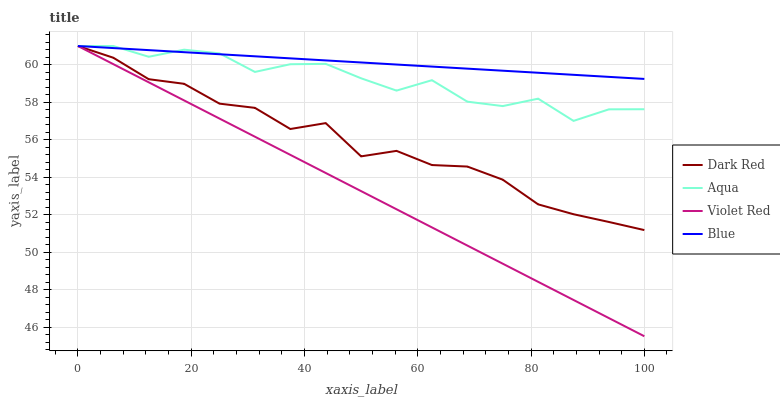Does Violet Red have the minimum area under the curve?
Answer yes or no. Yes. Does Blue have the maximum area under the curve?
Answer yes or no. Yes. Does Dark Red have the minimum area under the curve?
Answer yes or no. No. Does Dark Red have the maximum area under the curve?
Answer yes or no. No. Is Violet Red the smoothest?
Answer yes or no. Yes. Is Aqua the roughest?
Answer yes or no. Yes. Is Dark Red the smoothest?
Answer yes or no. No. Is Dark Red the roughest?
Answer yes or no. No. Does Dark Red have the lowest value?
Answer yes or no. No. 